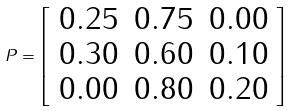Convert formula to latex. <formula><loc_0><loc_0><loc_500><loc_500>\ P = \left [ \begin{array} { c c c } 0 . 2 5 & 0 . 7 5 & 0 . 0 0 \\ 0 . 3 0 & 0 . 6 0 & 0 . 1 0 \\ 0 . 0 0 & 0 . 8 0 & 0 . 2 0 \end{array} \right ]</formula> 